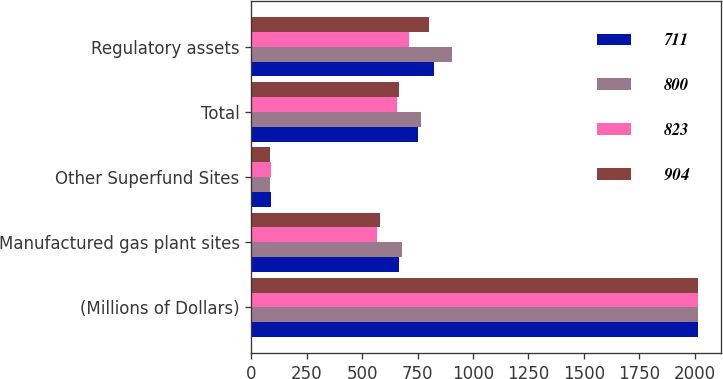Convert chart to OTSL. <chart><loc_0><loc_0><loc_500><loc_500><stacked_bar_chart><ecel><fcel>(Millions of Dollars)<fcel>Manufactured gas plant sites<fcel>Other Superfund Sites<fcel>Total<fcel>Regulatory assets<nl><fcel>711<fcel>2016<fcel>664<fcel>89<fcel>753<fcel>823<nl><fcel>800<fcel>2015<fcel>679<fcel>86<fcel>765<fcel>904<nl><fcel>823<fcel>2016<fcel>567<fcel>88<fcel>655<fcel>711<nl><fcel>904<fcel>2015<fcel>579<fcel>86<fcel>665<fcel>800<nl></chart> 